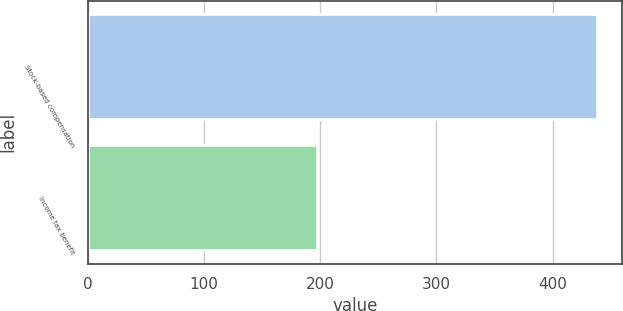Convert chart. <chart><loc_0><loc_0><loc_500><loc_500><bar_chart><fcel>Stock-based compensation<fcel>Income tax benefit<nl><fcel>438<fcel>197<nl></chart> 